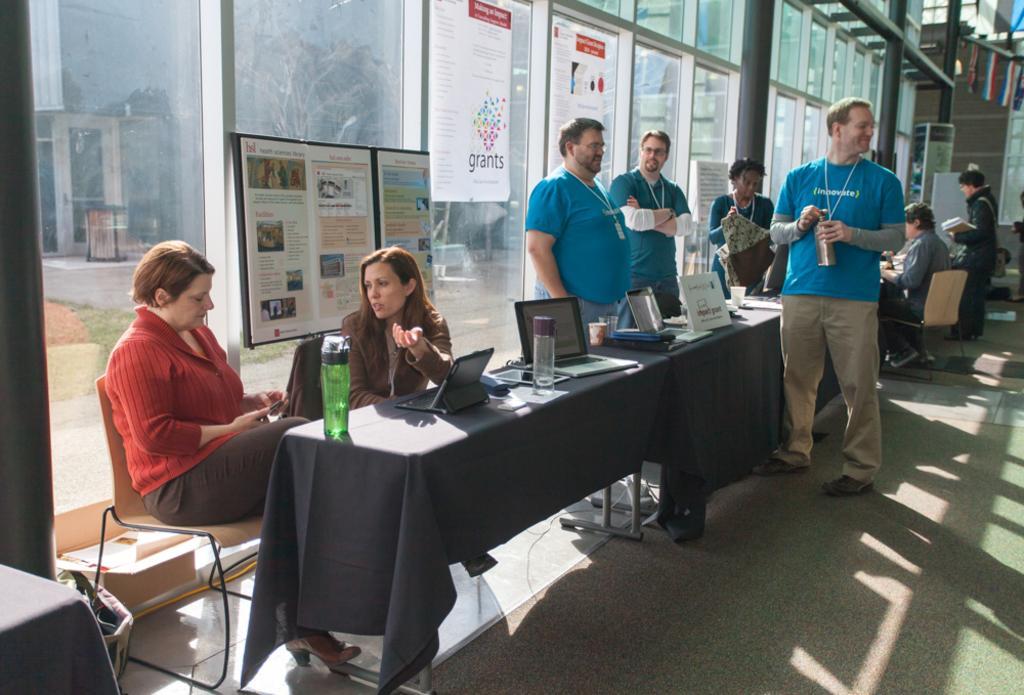In one or two sentences, can you explain what this image depicts? There are group of persons in this image, at the left side of the image two lady persons talking to each other and at the middle of the image there are three persons wearing blue color shirt standing and at the right side of the image there is a man standing carrying a backpack and holding a book in his hand and there are water bottles and laptops on the table and at the left side of the image there is a glass door 